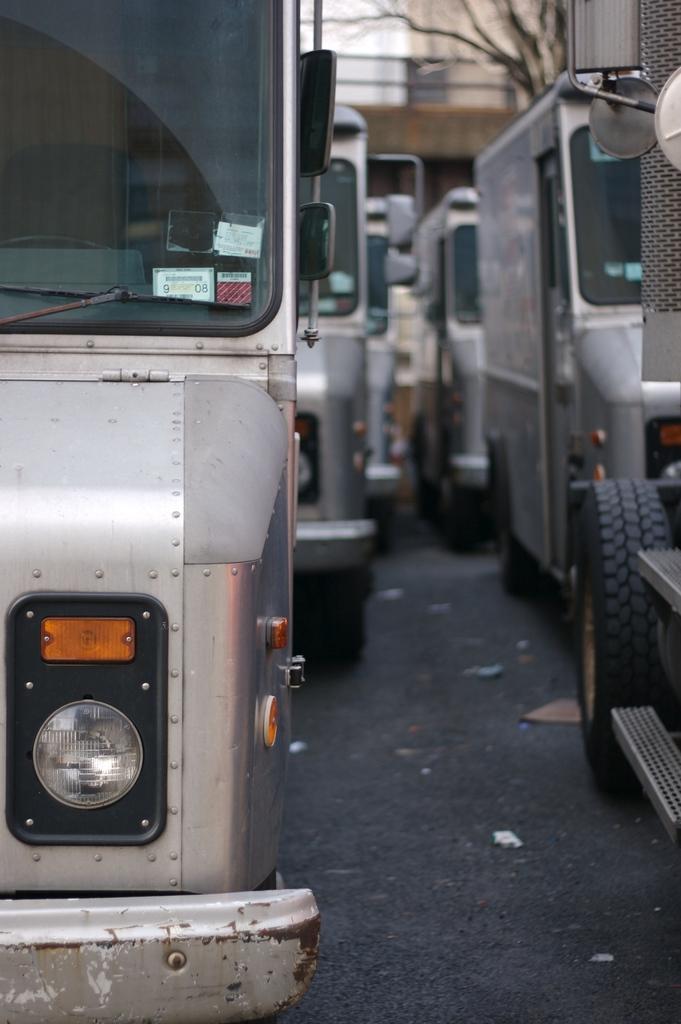Can you describe this image briefly? In this image, we can see some vans. 